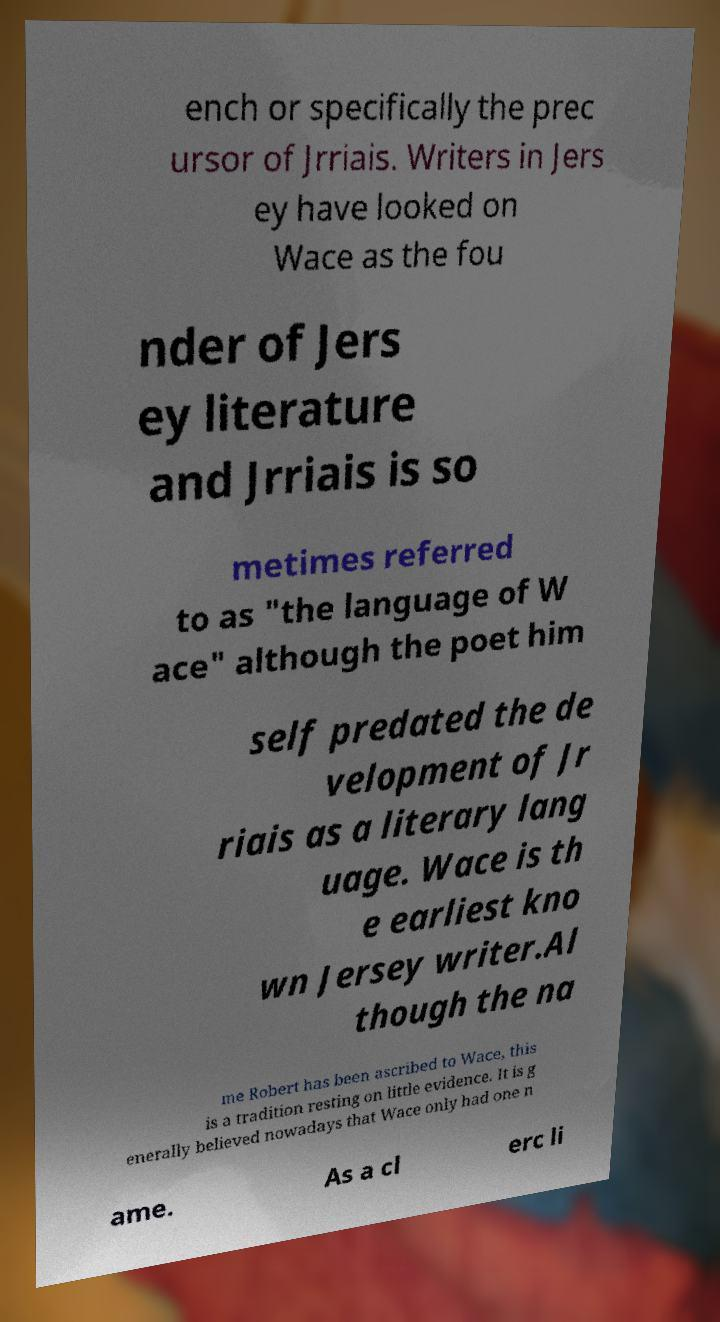What messages or text are displayed in this image? I need them in a readable, typed format. ench or specifically the prec ursor of Jrriais. Writers in Jers ey have looked on Wace as the fou nder of Jers ey literature and Jrriais is so metimes referred to as "the language of W ace" although the poet him self predated the de velopment of Jr riais as a literary lang uage. Wace is th e earliest kno wn Jersey writer.Al though the na me Robert has been ascribed to Wace, this is a tradition resting on little evidence. It is g enerally believed nowadays that Wace only had one n ame. As a cl erc li 